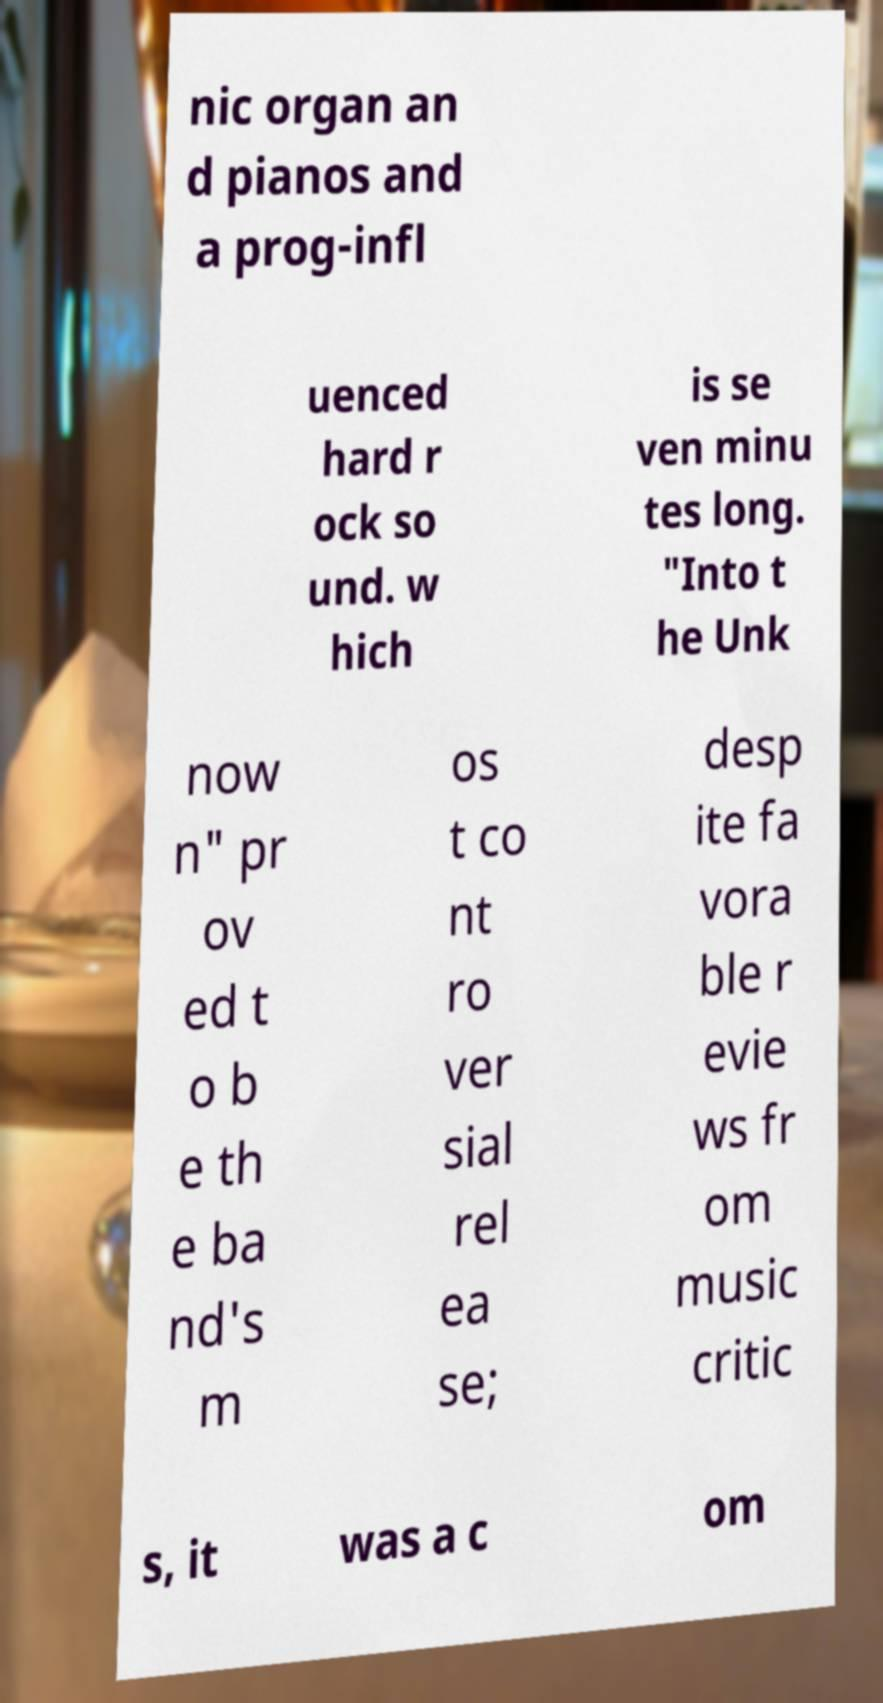Please identify and transcribe the text found in this image. nic organ an d pianos and a prog-infl uenced hard r ock so und. w hich is se ven minu tes long. "Into t he Unk now n" pr ov ed t o b e th e ba nd's m os t co nt ro ver sial rel ea se; desp ite fa vora ble r evie ws fr om music critic s, it was a c om 